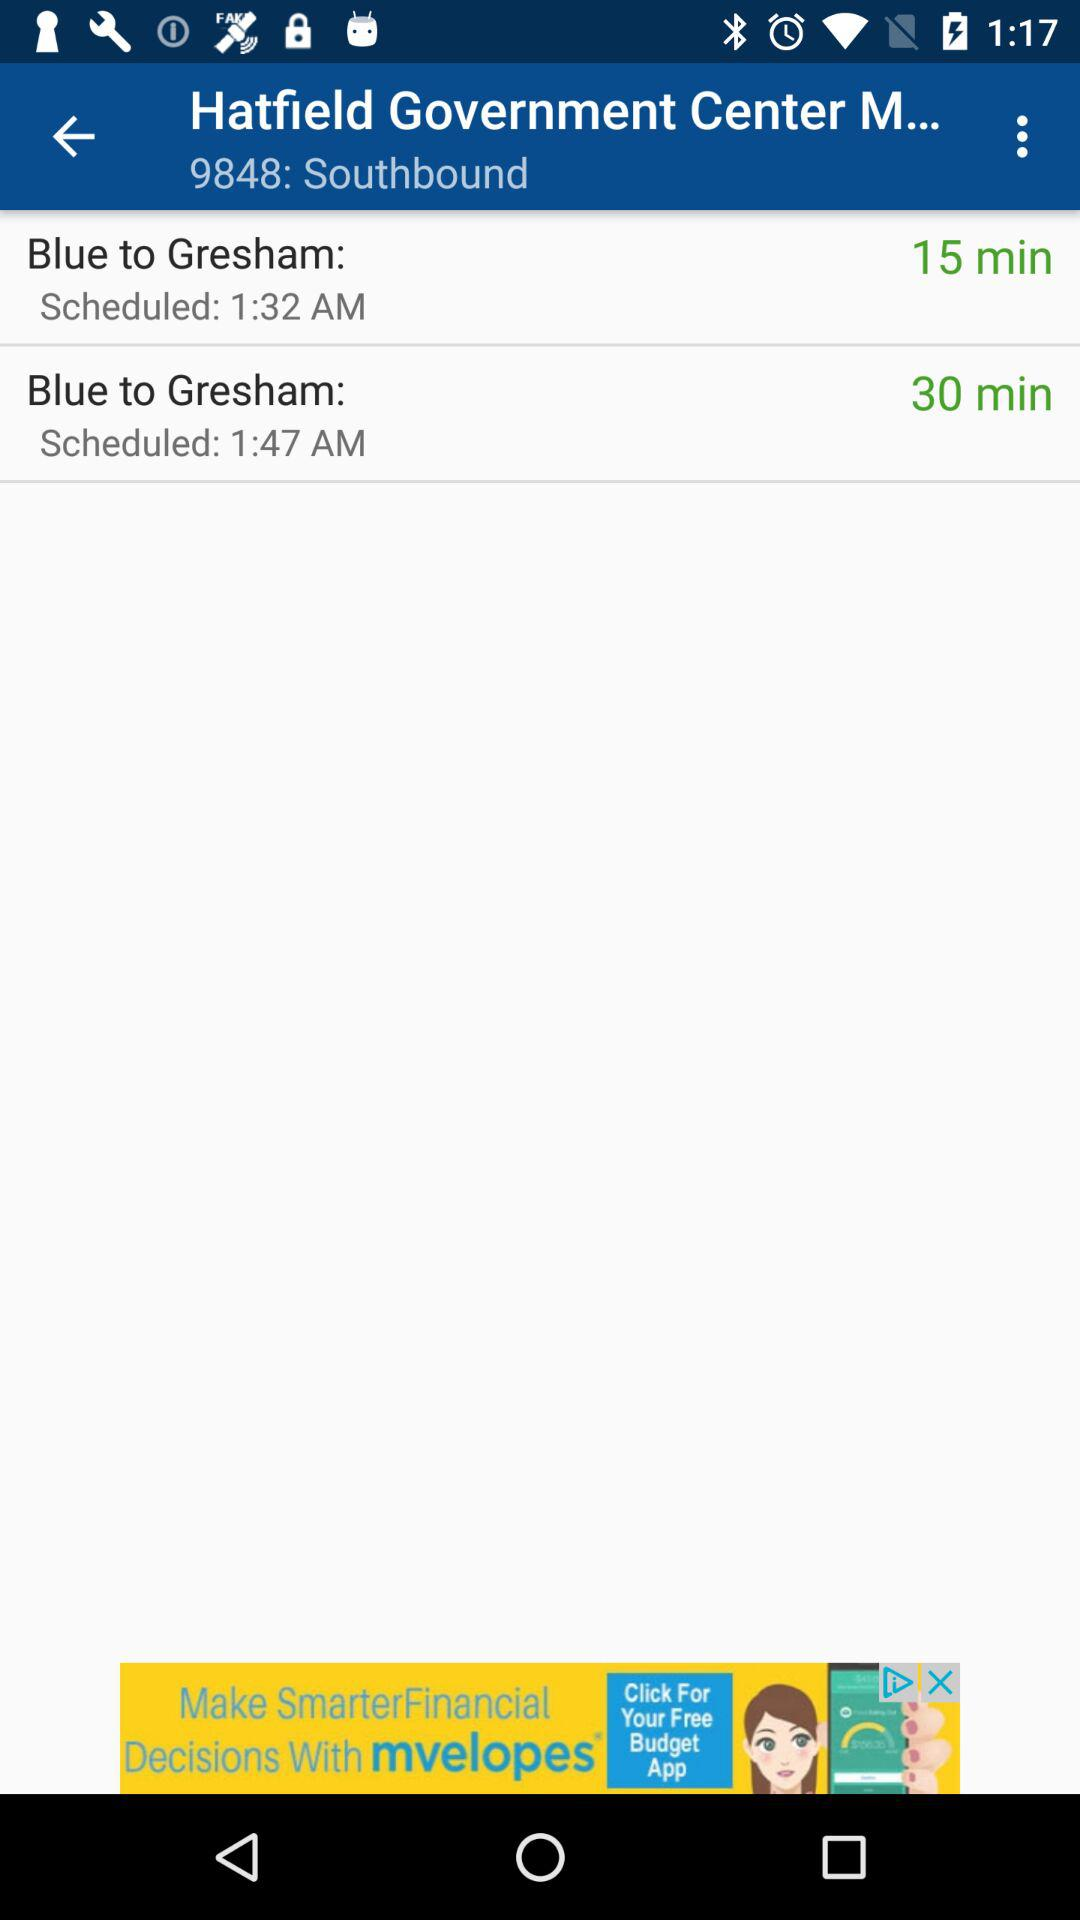How much does the trip cost?
When the provided information is insufficient, respond with <no answer>. <no answer> 